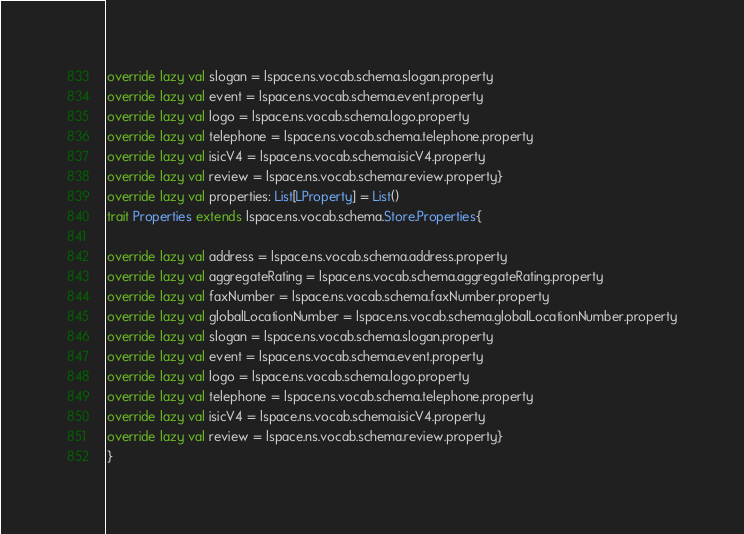<code> <loc_0><loc_0><loc_500><loc_500><_Scala_>override lazy val slogan = lspace.ns.vocab.schema.slogan.property
override lazy val event = lspace.ns.vocab.schema.event.property
override lazy val logo = lspace.ns.vocab.schema.logo.property
override lazy val telephone = lspace.ns.vocab.schema.telephone.property
override lazy val isicV4 = lspace.ns.vocab.schema.isicV4.property
override lazy val review = lspace.ns.vocab.schema.review.property}
override lazy val properties: List[LProperty] = List()
trait Properties extends lspace.ns.vocab.schema.Store.Properties{

override lazy val address = lspace.ns.vocab.schema.address.property
override lazy val aggregateRating = lspace.ns.vocab.schema.aggregateRating.property
override lazy val faxNumber = lspace.ns.vocab.schema.faxNumber.property
override lazy val globalLocationNumber = lspace.ns.vocab.schema.globalLocationNumber.property
override lazy val slogan = lspace.ns.vocab.schema.slogan.property
override lazy val event = lspace.ns.vocab.schema.event.property
override lazy val logo = lspace.ns.vocab.schema.logo.property
override lazy val telephone = lspace.ns.vocab.schema.telephone.property
override lazy val isicV4 = lspace.ns.vocab.schema.isicV4.property
override lazy val review = lspace.ns.vocab.schema.review.property}
}</code> 